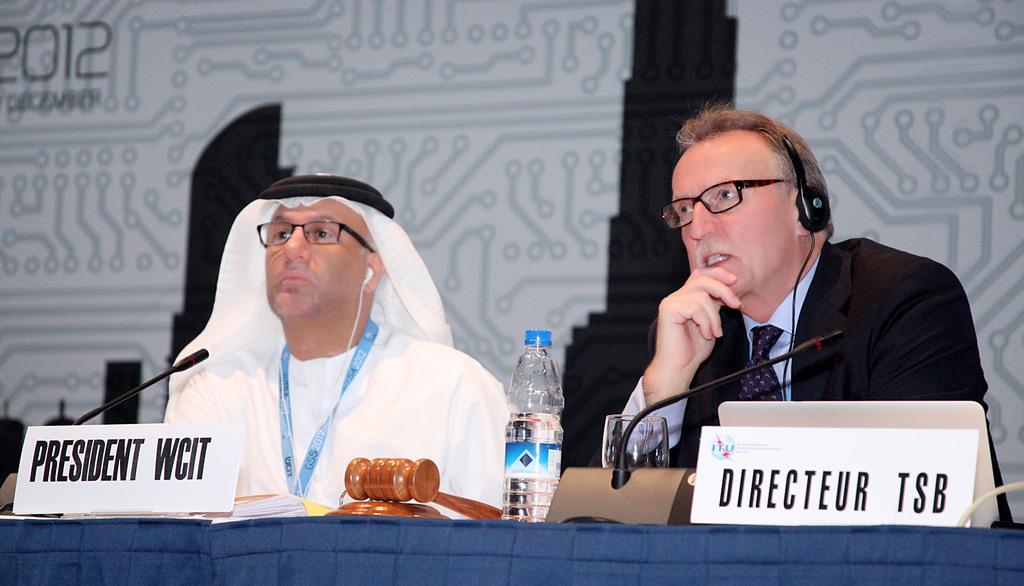In one or two sentences, can you explain what this image depicts? In this image I can see two people are sitting. In-front of them there is a table, on the table there are mics, glass, water bottle, name boards and objects. We can also see earphone and headset. In the background of the image there is a banner.   